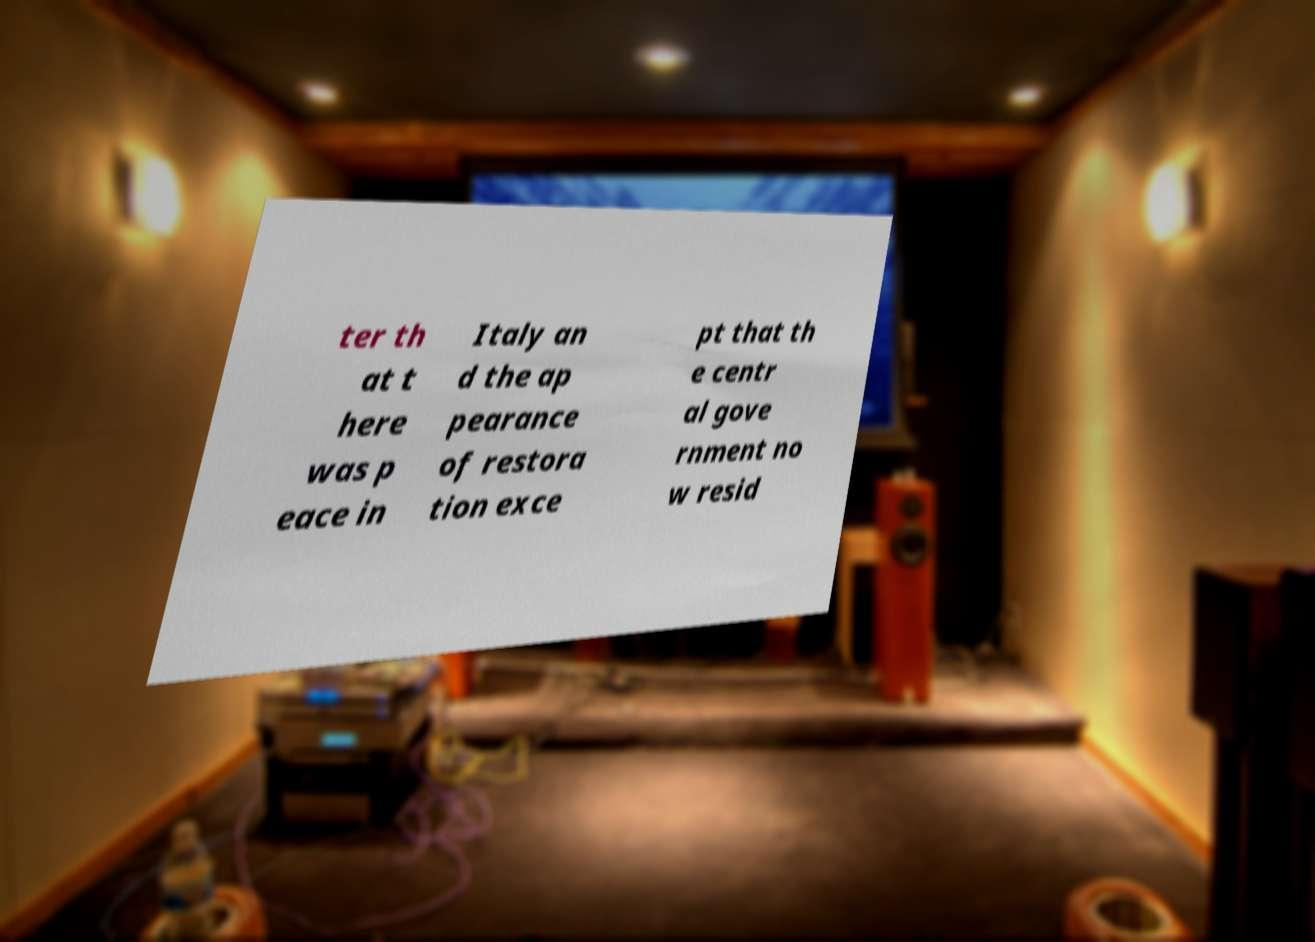I need the written content from this picture converted into text. Can you do that? ter th at t here was p eace in Italy an d the ap pearance of restora tion exce pt that th e centr al gove rnment no w resid 